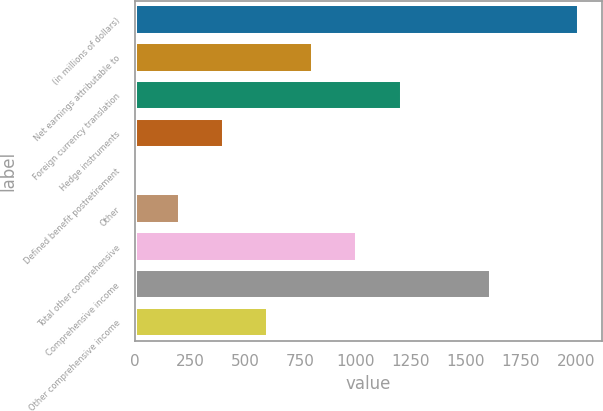Convert chart. <chart><loc_0><loc_0><loc_500><loc_500><bar_chart><fcel>(in millions of dollars)<fcel>Net earnings attributable to<fcel>Foreign currency translation<fcel>Hedge instruments<fcel>Defined benefit postretirement<fcel>Other<fcel>Total other comprehensive<fcel>Comprehensive income<fcel>Other comprehensive income<nl><fcel>2017<fcel>807.1<fcel>1210.4<fcel>403.8<fcel>0.5<fcel>202.15<fcel>1008.75<fcel>1613.7<fcel>605.45<nl></chart> 